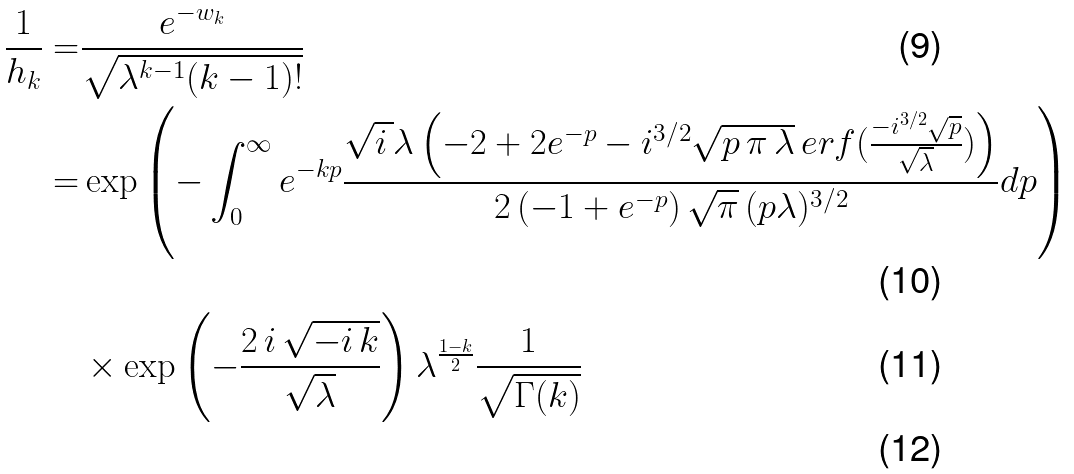Convert formula to latex. <formula><loc_0><loc_0><loc_500><loc_500>\frac { 1 } { h _ { k } } = & \frac { e ^ { - w _ { k } } } { \sqrt { \lambda ^ { k - 1 } ( k - 1 ) ! } } \\ = & \exp \left ( - \int _ { 0 } ^ { \infty } e ^ { - k p } \frac { \sqrt { i \, } \lambda \left ( - 2 + 2 e ^ { - p } - i ^ { 3 / 2 } \sqrt { p \, \pi \, \lambda } \, e r f ( \frac { - i ^ { 3 / 2 } \sqrt { p } } { \sqrt { \lambda } } ) \right ) } { 2 \, ( - 1 + e ^ { - p } ) \, \sqrt { \pi } \, ( p \lambda ) ^ { 3 / 2 } } d p \right ) \\ & \times \exp \left ( - \frac { 2 \, i \, \sqrt { - i \, k } } { \sqrt { \lambda } } \right ) \lambda ^ { \frac { 1 - k } { 2 } } \frac { 1 } { \sqrt { \Gamma ( k ) } } \\</formula> 